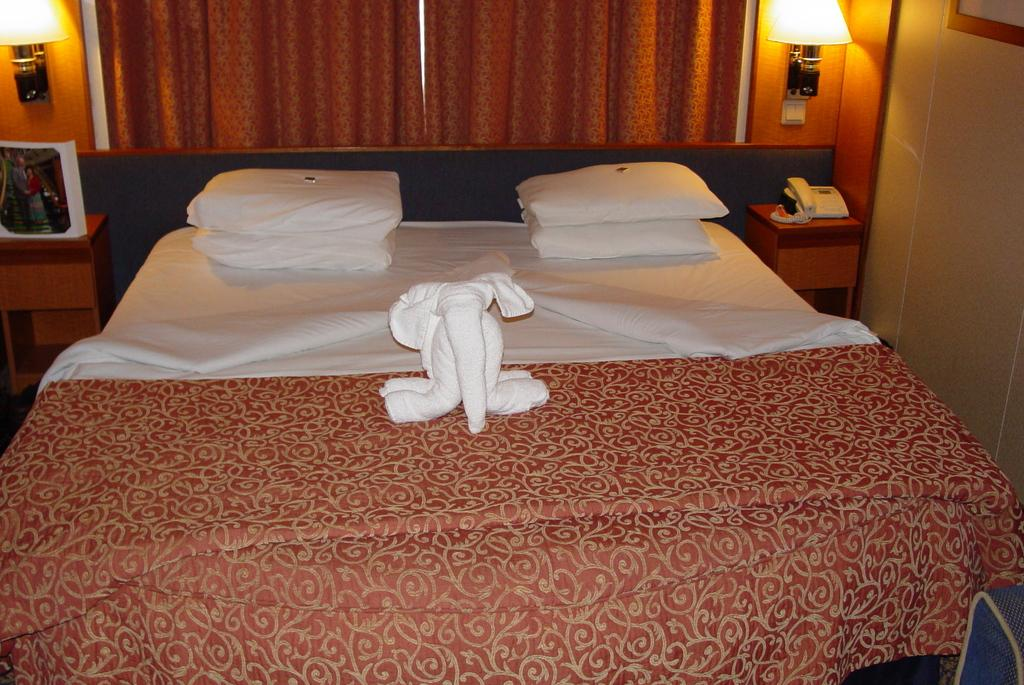What type of furniture is present in the image? There is a bed in the image. What accessories are on the bed? The bed has blankets and pillows. What can be seen on the bedside table? There is a photo and a landline telephone on a bedside table. What type of window treatment is visible in the image? There are curtains in the image. What type of lighting is present in the room? There are lamps in the image. Are there any other objects present in the room besides the bed, bedside table, curtains, and lamps? Yes, there are other objects present in the image. What type of wood is used to make the achiever's trophy in the image? There is no achiever or trophy present in the image. What type of wire is used to connect the lamps in the image? The image does not show the wiring of the lamps, so it cannot be determined from the image. 